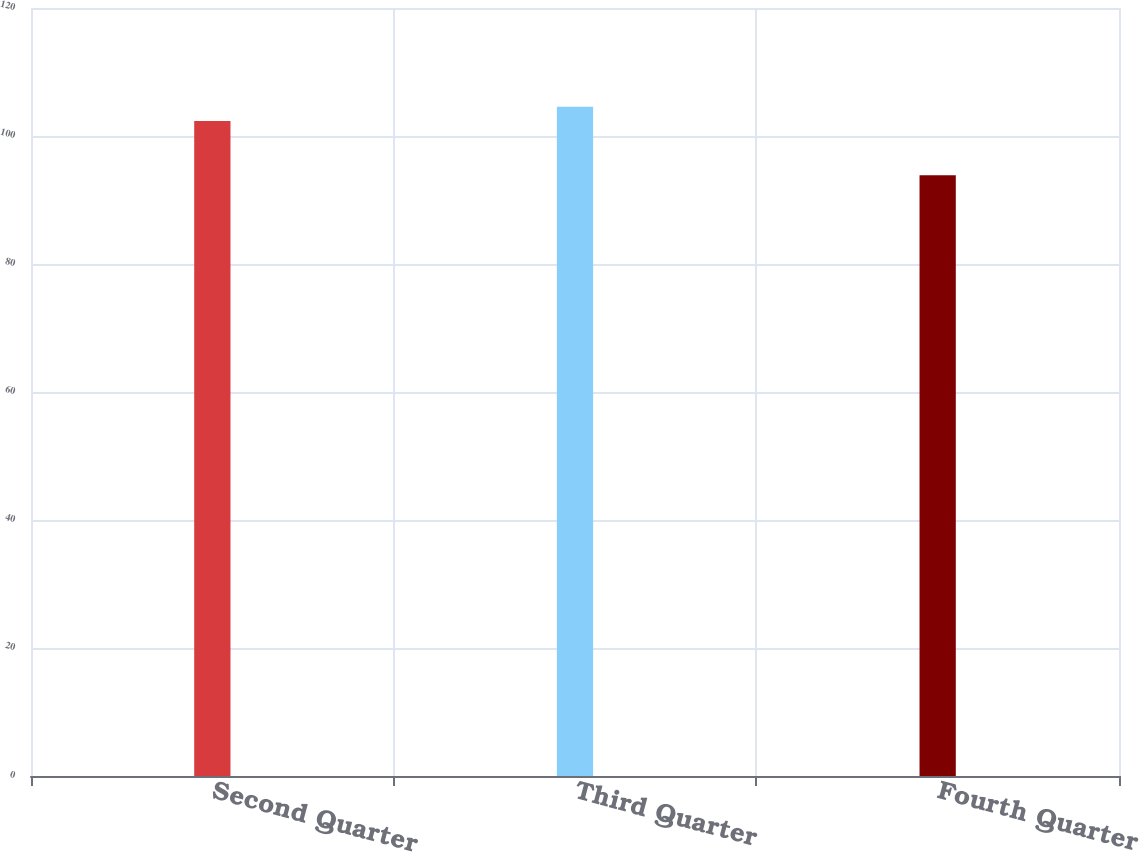<chart> <loc_0><loc_0><loc_500><loc_500><bar_chart><fcel>Second Quarter<fcel>Third Quarter<fcel>Fourth Quarter<nl><fcel>102.34<fcel>104.57<fcel>93.87<nl></chart> 